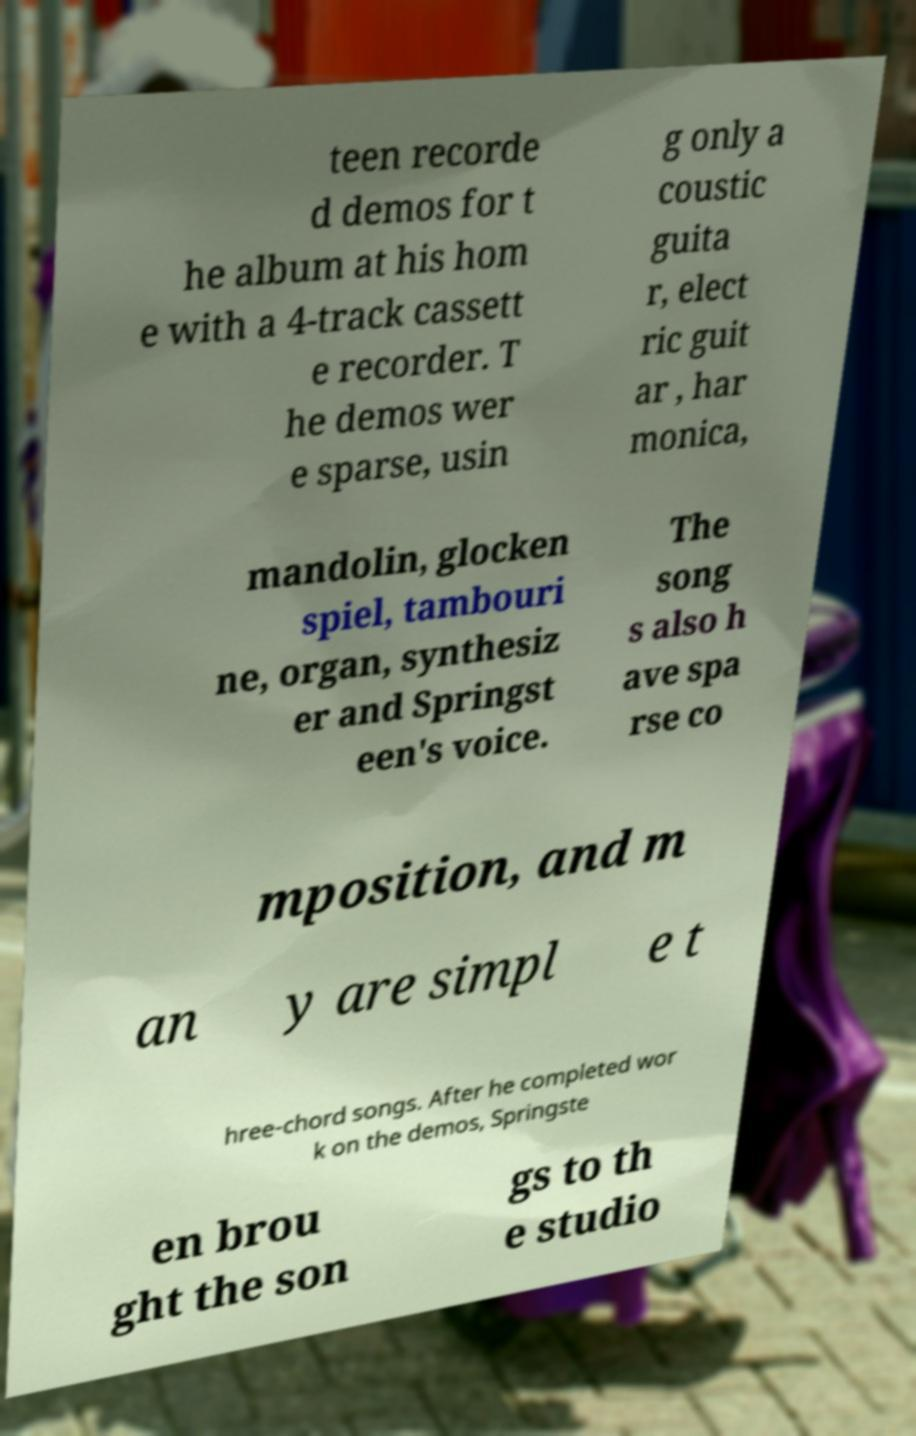Could you assist in decoding the text presented in this image and type it out clearly? teen recorde d demos for t he album at his hom e with a 4-track cassett e recorder. T he demos wer e sparse, usin g only a coustic guita r, elect ric guit ar , har monica, mandolin, glocken spiel, tambouri ne, organ, synthesiz er and Springst een's voice. The song s also h ave spa rse co mposition, and m an y are simpl e t hree-chord songs. After he completed wor k on the demos, Springste en brou ght the son gs to th e studio 